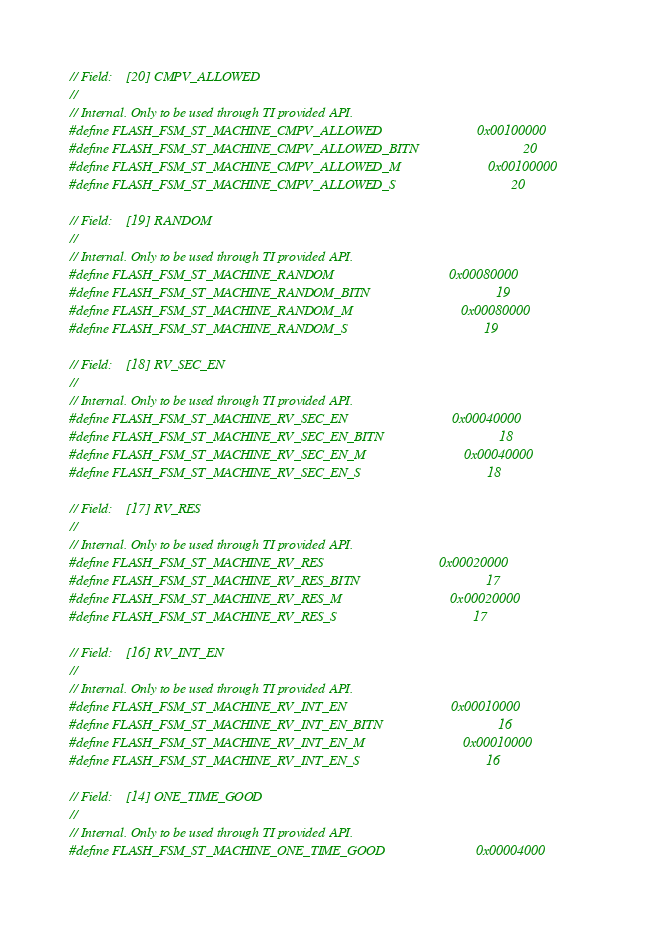Convert code to text. <code><loc_0><loc_0><loc_500><loc_500><_C_>
// Field:    [20] CMPV_ALLOWED
//
// Internal. Only to be used through TI provided API.
#define FLASH_FSM_ST_MACHINE_CMPV_ALLOWED                           0x00100000
#define FLASH_FSM_ST_MACHINE_CMPV_ALLOWED_BITN                              20
#define FLASH_FSM_ST_MACHINE_CMPV_ALLOWED_M                         0x00100000
#define FLASH_FSM_ST_MACHINE_CMPV_ALLOWED_S                                 20

// Field:    [19] RANDOM
//
// Internal. Only to be used through TI provided API.
#define FLASH_FSM_ST_MACHINE_RANDOM                                 0x00080000
#define FLASH_FSM_ST_MACHINE_RANDOM_BITN                                    19
#define FLASH_FSM_ST_MACHINE_RANDOM_M                               0x00080000
#define FLASH_FSM_ST_MACHINE_RANDOM_S                                       19

// Field:    [18] RV_SEC_EN
//
// Internal. Only to be used through TI provided API.
#define FLASH_FSM_ST_MACHINE_RV_SEC_EN                              0x00040000
#define FLASH_FSM_ST_MACHINE_RV_SEC_EN_BITN                                 18
#define FLASH_FSM_ST_MACHINE_RV_SEC_EN_M                            0x00040000
#define FLASH_FSM_ST_MACHINE_RV_SEC_EN_S                                    18

// Field:    [17] RV_RES
//
// Internal. Only to be used through TI provided API.
#define FLASH_FSM_ST_MACHINE_RV_RES                                 0x00020000
#define FLASH_FSM_ST_MACHINE_RV_RES_BITN                                    17
#define FLASH_FSM_ST_MACHINE_RV_RES_M                               0x00020000
#define FLASH_FSM_ST_MACHINE_RV_RES_S                                       17

// Field:    [16] RV_INT_EN
//
// Internal. Only to be used through TI provided API.
#define FLASH_FSM_ST_MACHINE_RV_INT_EN                              0x00010000
#define FLASH_FSM_ST_MACHINE_RV_INT_EN_BITN                                 16
#define FLASH_FSM_ST_MACHINE_RV_INT_EN_M                            0x00010000
#define FLASH_FSM_ST_MACHINE_RV_INT_EN_S                                    16

// Field:    [14] ONE_TIME_GOOD
//
// Internal. Only to be used through TI provided API.
#define FLASH_FSM_ST_MACHINE_ONE_TIME_GOOD                          0x00004000</code> 